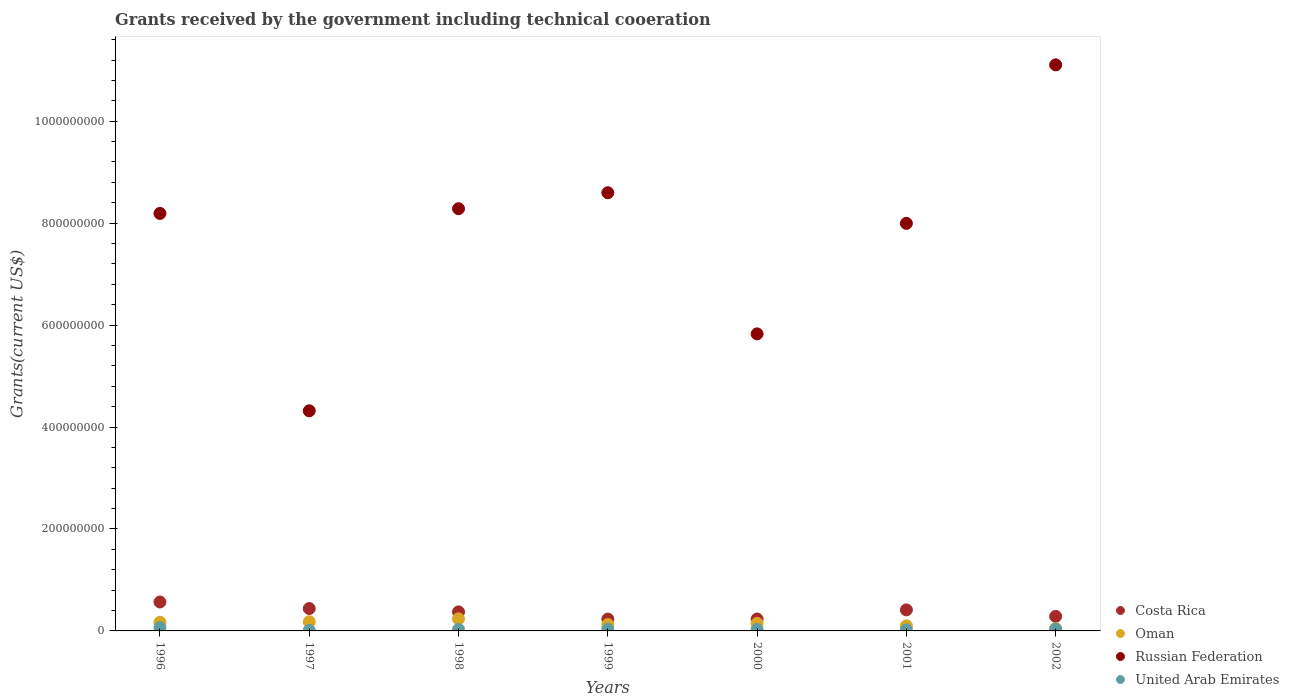How many different coloured dotlines are there?
Your response must be concise. 4. Is the number of dotlines equal to the number of legend labels?
Your response must be concise. Yes. What is the total grants received by the government in United Arab Emirates in 1999?
Keep it short and to the point. 3.33e+06. Across all years, what is the maximum total grants received by the government in Russian Federation?
Your answer should be compact. 1.11e+09. Across all years, what is the minimum total grants received by the government in Costa Rica?
Offer a very short reply. 2.33e+07. In which year was the total grants received by the government in United Arab Emirates maximum?
Your answer should be very brief. 1996. In which year was the total grants received by the government in Costa Rica minimum?
Offer a terse response. 1999. What is the total total grants received by the government in United Arab Emirates in the graph?
Offer a very short reply. 2.27e+07. What is the difference between the total grants received by the government in Costa Rica in 1998 and that in 2002?
Provide a succinct answer. 8.85e+06. What is the difference between the total grants received by the government in Russian Federation in 2001 and the total grants received by the government in United Arab Emirates in 2000?
Give a very brief answer. 7.97e+08. What is the average total grants received by the government in Oman per year?
Give a very brief answer. 1.43e+07. In the year 2000, what is the difference between the total grants received by the government in Russian Federation and total grants received by the government in United Arab Emirates?
Your response must be concise. 5.80e+08. What is the ratio of the total grants received by the government in Russian Federation in 1996 to that in 2002?
Make the answer very short. 0.74. Is the total grants received by the government in United Arab Emirates in 1996 less than that in 1998?
Ensure brevity in your answer.  No. Is the difference between the total grants received by the government in Russian Federation in 1996 and 1999 greater than the difference between the total grants received by the government in United Arab Emirates in 1996 and 1999?
Offer a very short reply. No. What is the difference between the highest and the second highest total grants received by the government in United Arab Emirates?
Your answer should be very brief. 3.23e+06. What is the difference between the highest and the lowest total grants received by the government in Costa Rica?
Offer a very short reply. 3.35e+07. Is it the case that in every year, the sum of the total grants received by the government in Costa Rica and total grants received by the government in Russian Federation  is greater than the total grants received by the government in Oman?
Keep it short and to the point. Yes. Is the total grants received by the government in Russian Federation strictly greater than the total grants received by the government in United Arab Emirates over the years?
Provide a succinct answer. Yes. Is the total grants received by the government in Oman strictly less than the total grants received by the government in Russian Federation over the years?
Provide a short and direct response. Yes. How many dotlines are there?
Provide a short and direct response. 4. Are the values on the major ticks of Y-axis written in scientific E-notation?
Ensure brevity in your answer.  No. Does the graph contain any zero values?
Your response must be concise. No. Where does the legend appear in the graph?
Offer a very short reply. Bottom right. How many legend labels are there?
Offer a terse response. 4. How are the legend labels stacked?
Offer a very short reply. Vertical. What is the title of the graph?
Offer a very short reply. Grants received by the government including technical cooeration. Does "Cambodia" appear as one of the legend labels in the graph?
Your answer should be compact. No. What is the label or title of the Y-axis?
Offer a terse response. Grants(current US$). What is the Grants(current US$) in Costa Rica in 1996?
Ensure brevity in your answer.  5.68e+07. What is the Grants(current US$) of Oman in 1996?
Make the answer very short. 1.68e+07. What is the Grants(current US$) in Russian Federation in 1996?
Offer a terse response. 8.19e+08. What is the Grants(current US$) in United Arab Emirates in 1996?
Offer a very short reply. 6.70e+06. What is the Grants(current US$) of Costa Rica in 1997?
Make the answer very short. 4.39e+07. What is the Grants(current US$) of Oman in 1997?
Give a very brief answer. 1.80e+07. What is the Grants(current US$) in Russian Federation in 1997?
Make the answer very short. 4.32e+08. What is the Grants(current US$) in United Arab Emirates in 1997?
Provide a succinct answer. 1.05e+06. What is the Grants(current US$) of Costa Rica in 1998?
Make the answer very short. 3.74e+07. What is the Grants(current US$) in Oman in 1998?
Provide a succinct answer. 2.37e+07. What is the Grants(current US$) in Russian Federation in 1998?
Keep it short and to the point. 8.28e+08. What is the Grants(current US$) in United Arab Emirates in 1998?
Give a very brief answer. 3.01e+06. What is the Grants(current US$) in Costa Rica in 1999?
Offer a terse response. 2.33e+07. What is the Grants(current US$) in Oman in 1999?
Ensure brevity in your answer.  1.25e+07. What is the Grants(current US$) of Russian Federation in 1999?
Give a very brief answer. 8.60e+08. What is the Grants(current US$) in United Arab Emirates in 1999?
Your answer should be compact. 3.33e+06. What is the Grants(current US$) of Costa Rica in 2000?
Make the answer very short. 2.34e+07. What is the Grants(current US$) of Oman in 2000?
Your answer should be compact. 1.48e+07. What is the Grants(current US$) of Russian Federation in 2000?
Make the answer very short. 5.83e+08. What is the Grants(current US$) of United Arab Emirates in 2000?
Your response must be concise. 3.03e+06. What is the Grants(current US$) in Costa Rica in 2001?
Provide a short and direct response. 4.13e+07. What is the Grants(current US$) in Oman in 2001?
Keep it short and to the point. 9.93e+06. What is the Grants(current US$) in Russian Federation in 2001?
Your answer should be very brief. 8.00e+08. What is the Grants(current US$) of United Arab Emirates in 2001?
Make the answer very short. 2.09e+06. What is the Grants(current US$) of Costa Rica in 2002?
Offer a terse response. 2.85e+07. What is the Grants(current US$) in Oman in 2002?
Offer a very short reply. 4.55e+06. What is the Grants(current US$) of Russian Federation in 2002?
Give a very brief answer. 1.11e+09. What is the Grants(current US$) of United Arab Emirates in 2002?
Your answer should be very brief. 3.47e+06. Across all years, what is the maximum Grants(current US$) of Costa Rica?
Offer a terse response. 5.68e+07. Across all years, what is the maximum Grants(current US$) of Oman?
Provide a short and direct response. 2.37e+07. Across all years, what is the maximum Grants(current US$) of Russian Federation?
Provide a short and direct response. 1.11e+09. Across all years, what is the maximum Grants(current US$) of United Arab Emirates?
Ensure brevity in your answer.  6.70e+06. Across all years, what is the minimum Grants(current US$) in Costa Rica?
Provide a succinct answer. 2.33e+07. Across all years, what is the minimum Grants(current US$) of Oman?
Your answer should be very brief. 4.55e+06. Across all years, what is the minimum Grants(current US$) in Russian Federation?
Provide a succinct answer. 4.32e+08. Across all years, what is the minimum Grants(current US$) in United Arab Emirates?
Your answer should be compact. 1.05e+06. What is the total Grants(current US$) of Costa Rica in the graph?
Provide a succinct answer. 2.54e+08. What is the total Grants(current US$) of Oman in the graph?
Your response must be concise. 1.00e+08. What is the total Grants(current US$) in Russian Federation in the graph?
Offer a very short reply. 5.43e+09. What is the total Grants(current US$) of United Arab Emirates in the graph?
Give a very brief answer. 2.27e+07. What is the difference between the Grants(current US$) in Costa Rica in 1996 and that in 1997?
Make the answer very short. 1.28e+07. What is the difference between the Grants(current US$) of Oman in 1996 and that in 1997?
Provide a short and direct response. -1.19e+06. What is the difference between the Grants(current US$) of Russian Federation in 1996 and that in 1997?
Your answer should be compact. 3.87e+08. What is the difference between the Grants(current US$) of United Arab Emirates in 1996 and that in 1997?
Offer a very short reply. 5.65e+06. What is the difference between the Grants(current US$) of Costa Rica in 1996 and that in 1998?
Give a very brief answer. 1.94e+07. What is the difference between the Grants(current US$) of Oman in 1996 and that in 1998?
Give a very brief answer. -6.86e+06. What is the difference between the Grants(current US$) of Russian Federation in 1996 and that in 1998?
Your response must be concise. -9.23e+06. What is the difference between the Grants(current US$) in United Arab Emirates in 1996 and that in 1998?
Offer a very short reply. 3.69e+06. What is the difference between the Grants(current US$) in Costa Rica in 1996 and that in 1999?
Your answer should be very brief. 3.35e+07. What is the difference between the Grants(current US$) of Oman in 1996 and that in 1999?
Your answer should be compact. 4.31e+06. What is the difference between the Grants(current US$) in Russian Federation in 1996 and that in 1999?
Give a very brief answer. -4.06e+07. What is the difference between the Grants(current US$) of United Arab Emirates in 1996 and that in 1999?
Ensure brevity in your answer.  3.37e+06. What is the difference between the Grants(current US$) of Costa Rica in 1996 and that in 2000?
Give a very brief answer. 3.34e+07. What is the difference between the Grants(current US$) of Oman in 1996 and that in 2000?
Your answer should be very brief. 2.08e+06. What is the difference between the Grants(current US$) in Russian Federation in 1996 and that in 2000?
Your answer should be compact. 2.36e+08. What is the difference between the Grants(current US$) of United Arab Emirates in 1996 and that in 2000?
Keep it short and to the point. 3.67e+06. What is the difference between the Grants(current US$) in Costa Rica in 1996 and that in 2001?
Ensure brevity in your answer.  1.55e+07. What is the difference between the Grants(current US$) of Oman in 1996 and that in 2001?
Give a very brief answer. 6.91e+06. What is the difference between the Grants(current US$) in Russian Federation in 1996 and that in 2001?
Make the answer very short. 1.95e+07. What is the difference between the Grants(current US$) in United Arab Emirates in 1996 and that in 2001?
Your response must be concise. 4.61e+06. What is the difference between the Grants(current US$) of Costa Rica in 1996 and that in 2002?
Your answer should be very brief. 2.83e+07. What is the difference between the Grants(current US$) in Oman in 1996 and that in 2002?
Give a very brief answer. 1.23e+07. What is the difference between the Grants(current US$) in Russian Federation in 1996 and that in 2002?
Provide a short and direct response. -2.91e+08. What is the difference between the Grants(current US$) of United Arab Emirates in 1996 and that in 2002?
Your answer should be very brief. 3.23e+06. What is the difference between the Grants(current US$) in Costa Rica in 1997 and that in 1998?
Make the answer very short. 6.58e+06. What is the difference between the Grants(current US$) in Oman in 1997 and that in 1998?
Offer a terse response. -5.67e+06. What is the difference between the Grants(current US$) in Russian Federation in 1997 and that in 1998?
Offer a terse response. -3.97e+08. What is the difference between the Grants(current US$) of United Arab Emirates in 1997 and that in 1998?
Give a very brief answer. -1.96e+06. What is the difference between the Grants(current US$) of Costa Rica in 1997 and that in 1999?
Provide a short and direct response. 2.07e+07. What is the difference between the Grants(current US$) of Oman in 1997 and that in 1999?
Provide a succinct answer. 5.50e+06. What is the difference between the Grants(current US$) of Russian Federation in 1997 and that in 1999?
Offer a very short reply. -4.28e+08. What is the difference between the Grants(current US$) in United Arab Emirates in 1997 and that in 1999?
Provide a short and direct response. -2.28e+06. What is the difference between the Grants(current US$) in Costa Rica in 1997 and that in 2000?
Provide a short and direct response. 2.05e+07. What is the difference between the Grants(current US$) of Oman in 1997 and that in 2000?
Ensure brevity in your answer.  3.27e+06. What is the difference between the Grants(current US$) of Russian Federation in 1997 and that in 2000?
Ensure brevity in your answer.  -1.51e+08. What is the difference between the Grants(current US$) in United Arab Emirates in 1997 and that in 2000?
Keep it short and to the point. -1.98e+06. What is the difference between the Grants(current US$) of Costa Rica in 1997 and that in 2001?
Offer a terse response. 2.66e+06. What is the difference between the Grants(current US$) in Oman in 1997 and that in 2001?
Ensure brevity in your answer.  8.10e+06. What is the difference between the Grants(current US$) of Russian Federation in 1997 and that in 2001?
Ensure brevity in your answer.  -3.68e+08. What is the difference between the Grants(current US$) of United Arab Emirates in 1997 and that in 2001?
Your response must be concise. -1.04e+06. What is the difference between the Grants(current US$) of Costa Rica in 1997 and that in 2002?
Your answer should be compact. 1.54e+07. What is the difference between the Grants(current US$) of Oman in 1997 and that in 2002?
Your answer should be compact. 1.35e+07. What is the difference between the Grants(current US$) of Russian Federation in 1997 and that in 2002?
Give a very brief answer. -6.79e+08. What is the difference between the Grants(current US$) of United Arab Emirates in 1997 and that in 2002?
Your response must be concise. -2.42e+06. What is the difference between the Grants(current US$) of Costa Rica in 1998 and that in 1999?
Your response must be concise. 1.41e+07. What is the difference between the Grants(current US$) of Oman in 1998 and that in 1999?
Offer a terse response. 1.12e+07. What is the difference between the Grants(current US$) of Russian Federation in 1998 and that in 1999?
Your response must be concise. -3.14e+07. What is the difference between the Grants(current US$) in United Arab Emirates in 1998 and that in 1999?
Offer a very short reply. -3.20e+05. What is the difference between the Grants(current US$) of Costa Rica in 1998 and that in 2000?
Your answer should be compact. 1.40e+07. What is the difference between the Grants(current US$) of Oman in 1998 and that in 2000?
Your response must be concise. 8.94e+06. What is the difference between the Grants(current US$) in Russian Federation in 1998 and that in 2000?
Make the answer very short. 2.46e+08. What is the difference between the Grants(current US$) in United Arab Emirates in 1998 and that in 2000?
Make the answer very short. -2.00e+04. What is the difference between the Grants(current US$) in Costa Rica in 1998 and that in 2001?
Keep it short and to the point. -3.92e+06. What is the difference between the Grants(current US$) in Oman in 1998 and that in 2001?
Provide a succinct answer. 1.38e+07. What is the difference between the Grants(current US$) of Russian Federation in 1998 and that in 2001?
Provide a short and direct response. 2.87e+07. What is the difference between the Grants(current US$) of United Arab Emirates in 1998 and that in 2001?
Provide a succinct answer. 9.20e+05. What is the difference between the Grants(current US$) in Costa Rica in 1998 and that in 2002?
Your response must be concise. 8.85e+06. What is the difference between the Grants(current US$) in Oman in 1998 and that in 2002?
Offer a terse response. 1.92e+07. What is the difference between the Grants(current US$) of Russian Federation in 1998 and that in 2002?
Provide a short and direct response. -2.82e+08. What is the difference between the Grants(current US$) of United Arab Emirates in 1998 and that in 2002?
Give a very brief answer. -4.60e+05. What is the difference between the Grants(current US$) of Costa Rica in 1999 and that in 2000?
Your answer should be compact. -1.30e+05. What is the difference between the Grants(current US$) of Oman in 1999 and that in 2000?
Offer a terse response. -2.23e+06. What is the difference between the Grants(current US$) in Russian Federation in 1999 and that in 2000?
Offer a terse response. 2.77e+08. What is the difference between the Grants(current US$) in United Arab Emirates in 1999 and that in 2000?
Give a very brief answer. 3.00e+05. What is the difference between the Grants(current US$) in Costa Rica in 1999 and that in 2001?
Make the answer very short. -1.80e+07. What is the difference between the Grants(current US$) in Oman in 1999 and that in 2001?
Offer a very short reply. 2.60e+06. What is the difference between the Grants(current US$) in Russian Federation in 1999 and that in 2001?
Provide a succinct answer. 6.01e+07. What is the difference between the Grants(current US$) in United Arab Emirates in 1999 and that in 2001?
Provide a succinct answer. 1.24e+06. What is the difference between the Grants(current US$) in Costa Rica in 1999 and that in 2002?
Your answer should be very brief. -5.23e+06. What is the difference between the Grants(current US$) of Oman in 1999 and that in 2002?
Provide a short and direct response. 7.98e+06. What is the difference between the Grants(current US$) of Russian Federation in 1999 and that in 2002?
Provide a succinct answer. -2.51e+08. What is the difference between the Grants(current US$) in United Arab Emirates in 1999 and that in 2002?
Provide a succinct answer. -1.40e+05. What is the difference between the Grants(current US$) in Costa Rica in 2000 and that in 2001?
Make the answer very short. -1.79e+07. What is the difference between the Grants(current US$) of Oman in 2000 and that in 2001?
Your answer should be very brief. 4.83e+06. What is the difference between the Grants(current US$) of Russian Federation in 2000 and that in 2001?
Ensure brevity in your answer.  -2.17e+08. What is the difference between the Grants(current US$) of United Arab Emirates in 2000 and that in 2001?
Ensure brevity in your answer.  9.40e+05. What is the difference between the Grants(current US$) in Costa Rica in 2000 and that in 2002?
Offer a very short reply. -5.10e+06. What is the difference between the Grants(current US$) in Oman in 2000 and that in 2002?
Your answer should be very brief. 1.02e+07. What is the difference between the Grants(current US$) of Russian Federation in 2000 and that in 2002?
Offer a very short reply. -5.28e+08. What is the difference between the Grants(current US$) of United Arab Emirates in 2000 and that in 2002?
Offer a very short reply. -4.40e+05. What is the difference between the Grants(current US$) of Costa Rica in 2001 and that in 2002?
Offer a terse response. 1.28e+07. What is the difference between the Grants(current US$) in Oman in 2001 and that in 2002?
Your answer should be very brief. 5.38e+06. What is the difference between the Grants(current US$) of Russian Federation in 2001 and that in 2002?
Your answer should be compact. -3.11e+08. What is the difference between the Grants(current US$) of United Arab Emirates in 2001 and that in 2002?
Your response must be concise. -1.38e+06. What is the difference between the Grants(current US$) in Costa Rica in 1996 and the Grants(current US$) in Oman in 1997?
Provide a short and direct response. 3.87e+07. What is the difference between the Grants(current US$) of Costa Rica in 1996 and the Grants(current US$) of Russian Federation in 1997?
Provide a succinct answer. -3.75e+08. What is the difference between the Grants(current US$) of Costa Rica in 1996 and the Grants(current US$) of United Arab Emirates in 1997?
Offer a terse response. 5.57e+07. What is the difference between the Grants(current US$) of Oman in 1996 and the Grants(current US$) of Russian Federation in 1997?
Your response must be concise. -4.15e+08. What is the difference between the Grants(current US$) of Oman in 1996 and the Grants(current US$) of United Arab Emirates in 1997?
Your answer should be very brief. 1.58e+07. What is the difference between the Grants(current US$) of Russian Federation in 1996 and the Grants(current US$) of United Arab Emirates in 1997?
Your answer should be very brief. 8.18e+08. What is the difference between the Grants(current US$) in Costa Rica in 1996 and the Grants(current US$) in Oman in 1998?
Provide a short and direct response. 3.31e+07. What is the difference between the Grants(current US$) of Costa Rica in 1996 and the Grants(current US$) of Russian Federation in 1998?
Your response must be concise. -7.72e+08. What is the difference between the Grants(current US$) in Costa Rica in 1996 and the Grants(current US$) in United Arab Emirates in 1998?
Make the answer very short. 5.38e+07. What is the difference between the Grants(current US$) in Oman in 1996 and the Grants(current US$) in Russian Federation in 1998?
Offer a very short reply. -8.12e+08. What is the difference between the Grants(current US$) in Oman in 1996 and the Grants(current US$) in United Arab Emirates in 1998?
Provide a succinct answer. 1.38e+07. What is the difference between the Grants(current US$) in Russian Federation in 1996 and the Grants(current US$) in United Arab Emirates in 1998?
Offer a terse response. 8.16e+08. What is the difference between the Grants(current US$) of Costa Rica in 1996 and the Grants(current US$) of Oman in 1999?
Provide a short and direct response. 4.42e+07. What is the difference between the Grants(current US$) in Costa Rica in 1996 and the Grants(current US$) in Russian Federation in 1999?
Your response must be concise. -8.03e+08. What is the difference between the Grants(current US$) of Costa Rica in 1996 and the Grants(current US$) of United Arab Emirates in 1999?
Your answer should be compact. 5.34e+07. What is the difference between the Grants(current US$) in Oman in 1996 and the Grants(current US$) in Russian Federation in 1999?
Your answer should be compact. -8.43e+08. What is the difference between the Grants(current US$) in Oman in 1996 and the Grants(current US$) in United Arab Emirates in 1999?
Give a very brief answer. 1.35e+07. What is the difference between the Grants(current US$) in Russian Federation in 1996 and the Grants(current US$) in United Arab Emirates in 1999?
Make the answer very short. 8.16e+08. What is the difference between the Grants(current US$) in Costa Rica in 1996 and the Grants(current US$) in Oman in 2000?
Offer a very short reply. 4.20e+07. What is the difference between the Grants(current US$) of Costa Rica in 1996 and the Grants(current US$) of Russian Federation in 2000?
Offer a very short reply. -5.26e+08. What is the difference between the Grants(current US$) of Costa Rica in 1996 and the Grants(current US$) of United Arab Emirates in 2000?
Offer a very short reply. 5.37e+07. What is the difference between the Grants(current US$) of Oman in 1996 and the Grants(current US$) of Russian Federation in 2000?
Make the answer very short. -5.66e+08. What is the difference between the Grants(current US$) of Oman in 1996 and the Grants(current US$) of United Arab Emirates in 2000?
Offer a terse response. 1.38e+07. What is the difference between the Grants(current US$) in Russian Federation in 1996 and the Grants(current US$) in United Arab Emirates in 2000?
Offer a terse response. 8.16e+08. What is the difference between the Grants(current US$) in Costa Rica in 1996 and the Grants(current US$) in Oman in 2001?
Your answer should be very brief. 4.68e+07. What is the difference between the Grants(current US$) in Costa Rica in 1996 and the Grants(current US$) in Russian Federation in 2001?
Make the answer very short. -7.43e+08. What is the difference between the Grants(current US$) of Costa Rica in 1996 and the Grants(current US$) of United Arab Emirates in 2001?
Offer a very short reply. 5.47e+07. What is the difference between the Grants(current US$) of Oman in 1996 and the Grants(current US$) of Russian Federation in 2001?
Provide a succinct answer. -7.83e+08. What is the difference between the Grants(current US$) of Oman in 1996 and the Grants(current US$) of United Arab Emirates in 2001?
Provide a succinct answer. 1.48e+07. What is the difference between the Grants(current US$) in Russian Federation in 1996 and the Grants(current US$) in United Arab Emirates in 2001?
Your response must be concise. 8.17e+08. What is the difference between the Grants(current US$) of Costa Rica in 1996 and the Grants(current US$) of Oman in 2002?
Your answer should be very brief. 5.22e+07. What is the difference between the Grants(current US$) in Costa Rica in 1996 and the Grants(current US$) in Russian Federation in 2002?
Provide a short and direct response. -1.05e+09. What is the difference between the Grants(current US$) of Costa Rica in 1996 and the Grants(current US$) of United Arab Emirates in 2002?
Your answer should be very brief. 5.33e+07. What is the difference between the Grants(current US$) of Oman in 1996 and the Grants(current US$) of Russian Federation in 2002?
Offer a terse response. -1.09e+09. What is the difference between the Grants(current US$) of Oman in 1996 and the Grants(current US$) of United Arab Emirates in 2002?
Your response must be concise. 1.34e+07. What is the difference between the Grants(current US$) in Russian Federation in 1996 and the Grants(current US$) in United Arab Emirates in 2002?
Your response must be concise. 8.16e+08. What is the difference between the Grants(current US$) in Costa Rica in 1997 and the Grants(current US$) in Oman in 1998?
Your response must be concise. 2.02e+07. What is the difference between the Grants(current US$) in Costa Rica in 1997 and the Grants(current US$) in Russian Federation in 1998?
Provide a succinct answer. -7.84e+08. What is the difference between the Grants(current US$) of Costa Rica in 1997 and the Grants(current US$) of United Arab Emirates in 1998?
Keep it short and to the point. 4.09e+07. What is the difference between the Grants(current US$) in Oman in 1997 and the Grants(current US$) in Russian Federation in 1998?
Your response must be concise. -8.10e+08. What is the difference between the Grants(current US$) of Oman in 1997 and the Grants(current US$) of United Arab Emirates in 1998?
Your answer should be compact. 1.50e+07. What is the difference between the Grants(current US$) in Russian Federation in 1997 and the Grants(current US$) in United Arab Emirates in 1998?
Make the answer very short. 4.29e+08. What is the difference between the Grants(current US$) in Costa Rica in 1997 and the Grants(current US$) in Oman in 1999?
Your answer should be compact. 3.14e+07. What is the difference between the Grants(current US$) of Costa Rica in 1997 and the Grants(current US$) of Russian Federation in 1999?
Give a very brief answer. -8.16e+08. What is the difference between the Grants(current US$) in Costa Rica in 1997 and the Grants(current US$) in United Arab Emirates in 1999?
Make the answer very short. 4.06e+07. What is the difference between the Grants(current US$) of Oman in 1997 and the Grants(current US$) of Russian Federation in 1999?
Your response must be concise. -8.42e+08. What is the difference between the Grants(current US$) in Oman in 1997 and the Grants(current US$) in United Arab Emirates in 1999?
Offer a terse response. 1.47e+07. What is the difference between the Grants(current US$) of Russian Federation in 1997 and the Grants(current US$) of United Arab Emirates in 1999?
Ensure brevity in your answer.  4.28e+08. What is the difference between the Grants(current US$) of Costa Rica in 1997 and the Grants(current US$) of Oman in 2000?
Offer a very short reply. 2.92e+07. What is the difference between the Grants(current US$) in Costa Rica in 1997 and the Grants(current US$) in Russian Federation in 2000?
Ensure brevity in your answer.  -5.39e+08. What is the difference between the Grants(current US$) in Costa Rica in 1997 and the Grants(current US$) in United Arab Emirates in 2000?
Give a very brief answer. 4.09e+07. What is the difference between the Grants(current US$) of Oman in 1997 and the Grants(current US$) of Russian Federation in 2000?
Give a very brief answer. -5.65e+08. What is the difference between the Grants(current US$) in Oman in 1997 and the Grants(current US$) in United Arab Emirates in 2000?
Give a very brief answer. 1.50e+07. What is the difference between the Grants(current US$) in Russian Federation in 1997 and the Grants(current US$) in United Arab Emirates in 2000?
Offer a terse response. 4.29e+08. What is the difference between the Grants(current US$) in Costa Rica in 1997 and the Grants(current US$) in Oman in 2001?
Keep it short and to the point. 3.40e+07. What is the difference between the Grants(current US$) in Costa Rica in 1997 and the Grants(current US$) in Russian Federation in 2001?
Keep it short and to the point. -7.56e+08. What is the difference between the Grants(current US$) of Costa Rica in 1997 and the Grants(current US$) of United Arab Emirates in 2001?
Give a very brief answer. 4.18e+07. What is the difference between the Grants(current US$) of Oman in 1997 and the Grants(current US$) of Russian Federation in 2001?
Make the answer very short. -7.82e+08. What is the difference between the Grants(current US$) in Oman in 1997 and the Grants(current US$) in United Arab Emirates in 2001?
Keep it short and to the point. 1.59e+07. What is the difference between the Grants(current US$) in Russian Federation in 1997 and the Grants(current US$) in United Arab Emirates in 2001?
Offer a terse response. 4.30e+08. What is the difference between the Grants(current US$) in Costa Rica in 1997 and the Grants(current US$) in Oman in 2002?
Your answer should be very brief. 3.94e+07. What is the difference between the Grants(current US$) in Costa Rica in 1997 and the Grants(current US$) in Russian Federation in 2002?
Provide a succinct answer. -1.07e+09. What is the difference between the Grants(current US$) of Costa Rica in 1997 and the Grants(current US$) of United Arab Emirates in 2002?
Keep it short and to the point. 4.05e+07. What is the difference between the Grants(current US$) of Oman in 1997 and the Grants(current US$) of Russian Federation in 2002?
Keep it short and to the point. -1.09e+09. What is the difference between the Grants(current US$) in Oman in 1997 and the Grants(current US$) in United Arab Emirates in 2002?
Your answer should be very brief. 1.46e+07. What is the difference between the Grants(current US$) of Russian Federation in 1997 and the Grants(current US$) of United Arab Emirates in 2002?
Offer a very short reply. 4.28e+08. What is the difference between the Grants(current US$) of Costa Rica in 1998 and the Grants(current US$) of Oman in 1999?
Give a very brief answer. 2.48e+07. What is the difference between the Grants(current US$) of Costa Rica in 1998 and the Grants(current US$) of Russian Federation in 1999?
Provide a short and direct response. -8.22e+08. What is the difference between the Grants(current US$) in Costa Rica in 1998 and the Grants(current US$) in United Arab Emirates in 1999?
Your answer should be compact. 3.40e+07. What is the difference between the Grants(current US$) in Oman in 1998 and the Grants(current US$) in Russian Federation in 1999?
Ensure brevity in your answer.  -8.36e+08. What is the difference between the Grants(current US$) in Oman in 1998 and the Grants(current US$) in United Arab Emirates in 1999?
Provide a succinct answer. 2.04e+07. What is the difference between the Grants(current US$) of Russian Federation in 1998 and the Grants(current US$) of United Arab Emirates in 1999?
Offer a terse response. 8.25e+08. What is the difference between the Grants(current US$) of Costa Rica in 1998 and the Grants(current US$) of Oman in 2000?
Offer a terse response. 2.26e+07. What is the difference between the Grants(current US$) of Costa Rica in 1998 and the Grants(current US$) of Russian Federation in 2000?
Offer a very short reply. -5.45e+08. What is the difference between the Grants(current US$) of Costa Rica in 1998 and the Grants(current US$) of United Arab Emirates in 2000?
Keep it short and to the point. 3.43e+07. What is the difference between the Grants(current US$) of Oman in 1998 and the Grants(current US$) of Russian Federation in 2000?
Provide a short and direct response. -5.59e+08. What is the difference between the Grants(current US$) in Oman in 1998 and the Grants(current US$) in United Arab Emirates in 2000?
Keep it short and to the point. 2.07e+07. What is the difference between the Grants(current US$) in Russian Federation in 1998 and the Grants(current US$) in United Arab Emirates in 2000?
Provide a succinct answer. 8.25e+08. What is the difference between the Grants(current US$) of Costa Rica in 1998 and the Grants(current US$) of Oman in 2001?
Offer a terse response. 2.74e+07. What is the difference between the Grants(current US$) in Costa Rica in 1998 and the Grants(current US$) in Russian Federation in 2001?
Ensure brevity in your answer.  -7.62e+08. What is the difference between the Grants(current US$) of Costa Rica in 1998 and the Grants(current US$) of United Arab Emirates in 2001?
Provide a succinct answer. 3.53e+07. What is the difference between the Grants(current US$) in Oman in 1998 and the Grants(current US$) in Russian Federation in 2001?
Ensure brevity in your answer.  -7.76e+08. What is the difference between the Grants(current US$) in Oman in 1998 and the Grants(current US$) in United Arab Emirates in 2001?
Ensure brevity in your answer.  2.16e+07. What is the difference between the Grants(current US$) of Russian Federation in 1998 and the Grants(current US$) of United Arab Emirates in 2001?
Your response must be concise. 8.26e+08. What is the difference between the Grants(current US$) in Costa Rica in 1998 and the Grants(current US$) in Oman in 2002?
Make the answer very short. 3.28e+07. What is the difference between the Grants(current US$) of Costa Rica in 1998 and the Grants(current US$) of Russian Federation in 2002?
Provide a short and direct response. -1.07e+09. What is the difference between the Grants(current US$) in Costa Rica in 1998 and the Grants(current US$) in United Arab Emirates in 2002?
Give a very brief answer. 3.39e+07. What is the difference between the Grants(current US$) of Oman in 1998 and the Grants(current US$) of Russian Federation in 2002?
Your answer should be very brief. -1.09e+09. What is the difference between the Grants(current US$) of Oman in 1998 and the Grants(current US$) of United Arab Emirates in 2002?
Keep it short and to the point. 2.02e+07. What is the difference between the Grants(current US$) of Russian Federation in 1998 and the Grants(current US$) of United Arab Emirates in 2002?
Provide a succinct answer. 8.25e+08. What is the difference between the Grants(current US$) in Costa Rica in 1999 and the Grants(current US$) in Oman in 2000?
Give a very brief answer. 8.51e+06. What is the difference between the Grants(current US$) in Costa Rica in 1999 and the Grants(current US$) in Russian Federation in 2000?
Provide a succinct answer. -5.60e+08. What is the difference between the Grants(current US$) in Costa Rica in 1999 and the Grants(current US$) in United Arab Emirates in 2000?
Keep it short and to the point. 2.02e+07. What is the difference between the Grants(current US$) in Oman in 1999 and the Grants(current US$) in Russian Federation in 2000?
Ensure brevity in your answer.  -5.70e+08. What is the difference between the Grants(current US$) in Oman in 1999 and the Grants(current US$) in United Arab Emirates in 2000?
Offer a terse response. 9.50e+06. What is the difference between the Grants(current US$) in Russian Federation in 1999 and the Grants(current US$) in United Arab Emirates in 2000?
Your answer should be very brief. 8.57e+08. What is the difference between the Grants(current US$) of Costa Rica in 1999 and the Grants(current US$) of Oman in 2001?
Give a very brief answer. 1.33e+07. What is the difference between the Grants(current US$) in Costa Rica in 1999 and the Grants(current US$) in Russian Federation in 2001?
Ensure brevity in your answer.  -7.76e+08. What is the difference between the Grants(current US$) of Costa Rica in 1999 and the Grants(current US$) of United Arab Emirates in 2001?
Keep it short and to the point. 2.12e+07. What is the difference between the Grants(current US$) in Oman in 1999 and the Grants(current US$) in Russian Federation in 2001?
Your response must be concise. -7.87e+08. What is the difference between the Grants(current US$) in Oman in 1999 and the Grants(current US$) in United Arab Emirates in 2001?
Ensure brevity in your answer.  1.04e+07. What is the difference between the Grants(current US$) in Russian Federation in 1999 and the Grants(current US$) in United Arab Emirates in 2001?
Your response must be concise. 8.58e+08. What is the difference between the Grants(current US$) of Costa Rica in 1999 and the Grants(current US$) of Oman in 2002?
Make the answer very short. 1.87e+07. What is the difference between the Grants(current US$) in Costa Rica in 1999 and the Grants(current US$) in Russian Federation in 2002?
Your answer should be very brief. -1.09e+09. What is the difference between the Grants(current US$) in Costa Rica in 1999 and the Grants(current US$) in United Arab Emirates in 2002?
Give a very brief answer. 1.98e+07. What is the difference between the Grants(current US$) of Oman in 1999 and the Grants(current US$) of Russian Federation in 2002?
Give a very brief answer. -1.10e+09. What is the difference between the Grants(current US$) of Oman in 1999 and the Grants(current US$) of United Arab Emirates in 2002?
Your answer should be compact. 9.06e+06. What is the difference between the Grants(current US$) in Russian Federation in 1999 and the Grants(current US$) in United Arab Emirates in 2002?
Make the answer very short. 8.56e+08. What is the difference between the Grants(current US$) of Costa Rica in 2000 and the Grants(current US$) of Oman in 2001?
Offer a very short reply. 1.35e+07. What is the difference between the Grants(current US$) in Costa Rica in 2000 and the Grants(current US$) in Russian Federation in 2001?
Your response must be concise. -7.76e+08. What is the difference between the Grants(current US$) in Costa Rica in 2000 and the Grants(current US$) in United Arab Emirates in 2001?
Offer a very short reply. 2.13e+07. What is the difference between the Grants(current US$) of Oman in 2000 and the Grants(current US$) of Russian Federation in 2001?
Your answer should be very brief. -7.85e+08. What is the difference between the Grants(current US$) in Oman in 2000 and the Grants(current US$) in United Arab Emirates in 2001?
Offer a very short reply. 1.27e+07. What is the difference between the Grants(current US$) of Russian Federation in 2000 and the Grants(current US$) of United Arab Emirates in 2001?
Offer a very short reply. 5.81e+08. What is the difference between the Grants(current US$) of Costa Rica in 2000 and the Grants(current US$) of Oman in 2002?
Your response must be concise. 1.88e+07. What is the difference between the Grants(current US$) in Costa Rica in 2000 and the Grants(current US$) in Russian Federation in 2002?
Your answer should be compact. -1.09e+09. What is the difference between the Grants(current US$) of Costa Rica in 2000 and the Grants(current US$) of United Arab Emirates in 2002?
Provide a short and direct response. 1.99e+07. What is the difference between the Grants(current US$) in Oman in 2000 and the Grants(current US$) in Russian Federation in 2002?
Make the answer very short. -1.10e+09. What is the difference between the Grants(current US$) of Oman in 2000 and the Grants(current US$) of United Arab Emirates in 2002?
Ensure brevity in your answer.  1.13e+07. What is the difference between the Grants(current US$) of Russian Federation in 2000 and the Grants(current US$) of United Arab Emirates in 2002?
Provide a short and direct response. 5.79e+08. What is the difference between the Grants(current US$) in Costa Rica in 2001 and the Grants(current US$) in Oman in 2002?
Keep it short and to the point. 3.67e+07. What is the difference between the Grants(current US$) in Costa Rica in 2001 and the Grants(current US$) in Russian Federation in 2002?
Offer a terse response. -1.07e+09. What is the difference between the Grants(current US$) of Costa Rica in 2001 and the Grants(current US$) of United Arab Emirates in 2002?
Give a very brief answer. 3.78e+07. What is the difference between the Grants(current US$) in Oman in 2001 and the Grants(current US$) in Russian Federation in 2002?
Offer a very short reply. -1.10e+09. What is the difference between the Grants(current US$) in Oman in 2001 and the Grants(current US$) in United Arab Emirates in 2002?
Your answer should be compact. 6.46e+06. What is the difference between the Grants(current US$) in Russian Federation in 2001 and the Grants(current US$) in United Arab Emirates in 2002?
Provide a short and direct response. 7.96e+08. What is the average Grants(current US$) of Costa Rica per year?
Your answer should be very brief. 3.64e+07. What is the average Grants(current US$) in Oman per year?
Provide a short and direct response. 1.43e+07. What is the average Grants(current US$) in Russian Federation per year?
Provide a succinct answer. 7.76e+08. What is the average Grants(current US$) in United Arab Emirates per year?
Provide a short and direct response. 3.24e+06. In the year 1996, what is the difference between the Grants(current US$) of Costa Rica and Grants(current US$) of Oman?
Make the answer very short. 3.99e+07. In the year 1996, what is the difference between the Grants(current US$) in Costa Rica and Grants(current US$) in Russian Federation?
Provide a succinct answer. -7.62e+08. In the year 1996, what is the difference between the Grants(current US$) in Costa Rica and Grants(current US$) in United Arab Emirates?
Your answer should be very brief. 5.01e+07. In the year 1996, what is the difference between the Grants(current US$) in Oman and Grants(current US$) in Russian Federation?
Provide a short and direct response. -8.02e+08. In the year 1996, what is the difference between the Grants(current US$) in Oman and Grants(current US$) in United Arab Emirates?
Give a very brief answer. 1.01e+07. In the year 1996, what is the difference between the Grants(current US$) of Russian Federation and Grants(current US$) of United Arab Emirates?
Provide a short and direct response. 8.12e+08. In the year 1997, what is the difference between the Grants(current US$) of Costa Rica and Grants(current US$) of Oman?
Your answer should be very brief. 2.59e+07. In the year 1997, what is the difference between the Grants(current US$) in Costa Rica and Grants(current US$) in Russian Federation?
Provide a succinct answer. -3.88e+08. In the year 1997, what is the difference between the Grants(current US$) of Costa Rica and Grants(current US$) of United Arab Emirates?
Offer a terse response. 4.29e+07. In the year 1997, what is the difference between the Grants(current US$) in Oman and Grants(current US$) in Russian Federation?
Keep it short and to the point. -4.14e+08. In the year 1997, what is the difference between the Grants(current US$) of Oman and Grants(current US$) of United Arab Emirates?
Ensure brevity in your answer.  1.70e+07. In the year 1997, what is the difference between the Grants(current US$) in Russian Federation and Grants(current US$) in United Arab Emirates?
Keep it short and to the point. 4.31e+08. In the year 1998, what is the difference between the Grants(current US$) of Costa Rica and Grants(current US$) of Oman?
Provide a short and direct response. 1.36e+07. In the year 1998, what is the difference between the Grants(current US$) in Costa Rica and Grants(current US$) in Russian Federation?
Ensure brevity in your answer.  -7.91e+08. In the year 1998, what is the difference between the Grants(current US$) in Costa Rica and Grants(current US$) in United Arab Emirates?
Your answer should be very brief. 3.43e+07. In the year 1998, what is the difference between the Grants(current US$) in Oman and Grants(current US$) in Russian Federation?
Offer a terse response. -8.05e+08. In the year 1998, what is the difference between the Grants(current US$) of Oman and Grants(current US$) of United Arab Emirates?
Your answer should be compact. 2.07e+07. In the year 1998, what is the difference between the Grants(current US$) in Russian Federation and Grants(current US$) in United Arab Emirates?
Ensure brevity in your answer.  8.25e+08. In the year 1999, what is the difference between the Grants(current US$) in Costa Rica and Grants(current US$) in Oman?
Ensure brevity in your answer.  1.07e+07. In the year 1999, what is the difference between the Grants(current US$) of Costa Rica and Grants(current US$) of Russian Federation?
Your answer should be very brief. -8.36e+08. In the year 1999, what is the difference between the Grants(current US$) in Costa Rica and Grants(current US$) in United Arab Emirates?
Ensure brevity in your answer.  1.99e+07. In the year 1999, what is the difference between the Grants(current US$) of Oman and Grants(current US$) of Russian Federation?
Offer a terse response. -8.47e+08. In the year 1999, what is the difference between the Grants(current US$) of Oman and Grants(current US$) of United Arab Emirates?
Make the answer very short. 9.20e+06. In the year 1999, what is the difference between the Grants(current US$) of Russian Federation and Grants(current US$) of United Arab Emirates?
Your answer should be compact. 8.56e+08. In the year 2000, what is the difference between the Grants(current US$) in Costa Rica and Grants(current US$) in Oman?
Make the answer very short. 8.64e+06. In the year 2000, what is the difference between the Grants(current US$) in Costa Rica and Grants(current US$) in Russian Federation?
Ensure brevity in your answer.  -5.59e+08. In the year 2000, what is the difference between the Grants(current US$) of Costa Rica and Grants(current US$) of United Arab Emirates?
Your answer should be compact. 2.04e+07. In the year 2000, what is the difference between the Grants(current US$) in Oman and Grants(current US$) in Russian Federation?
Your response must be concise. -5.68e+08. In the year 2000, what is the difference between the Grants(current US$) in Oman and Grants(current US$) in United Arab Emirates?
Keep it short and to the point. 1.17e+07. In the year 2000, what is the difference between the Grants(current US$) of Russian Federation and Grants(current US$) of United Arab Emirates?
Your response must be concise. 5.80e+08. In the year 2001, what is the difference between the Grants(current US$) of Costa Rica and Grants(current US$) of Oman?
Your response must be concise. 3.13e+07. In the year 2001, what is the difference between the Grants(current US$) of Costa Rica and Grants(current US$) of Russian Federation?
Your answer should be very brief. -7.58e+08. In the year 2001, what is the difference between the Grants(current US$) in Costa Rica and Grants(current US$) in United Arab Emirates?
Keep it short and to the point. 3.92e+07. In the year 2001, what is the difference between the Grants(current US$) of Oman and Grants(current US$) of Russian Federation?
Provide a succinct answer. -7.90e+08. In the year 2001, what is the difference between the Grants(current US$) of Oman and Grants(current US$) of United Arab Emirates?
Offer a terse response. 7.84e+06. In the year 2001, what is the difference between the Grants(current US$) in Russian Federation and Grants(current US$) in United Arab Emirates?
Your answer should be very brief. 7.98e+08. In the year 2002, what is the difference between the Grants(current US$) in Costa Rica and Grants(current US$) in Oman?
Provide a succinct answer. 2.40e+07. In the year 2002, what is the difference between the Grants(current US$) in Costa Rica and Grants(current US$) in Russian Federation?
Provide a succinct answer. -1.08e+09. In the year 2002, what is the difference between the Grants(current US$) of Costa Rica and Grants(current US$) of United Arab Emirates?
Provide a short and direct response. 2.50e+07. In the year 2002, what is the difference between the Grants(current US$) of Oman and Grants(current US$) of Russian Federation?
Offer a terse response. -1.11e+09. In the year 2002, what is the difference between the Grants(current US$) in Oman and Grants(current US$) in United Arab Emirates?
Provide a short and direct response. 1.08e+06. In the year 2002, what is the difference between the Grants(current US$) in Russian Federation and Grants(current US$) in United Arab Emirates?
Provide a succinct answer. 1.11e+09. What is the ratio of the Grants(current US$) in Costa Rica in 1996 to that in 1997?
Your response must be concise. 1.29. What is the ratio of the Grants(current US$) of Oman in 1996 to that in 1997?
Ensure brevity in your answer.  0.93. What is the ratio of the Grants(current US$) of Russian Federation in 1996 to that in 1997?
Keep it short and to the point. 1.9. What is the ratio of the Grants(current US$) of United Arab Emirates in 1996 to that in 1997?
Make the answer very short. 6.38. What is the ratio of the Grants(current US$) of Costa Rica in 1996 to that in 1998?
Offer a very short reply. 1.52. What is the ratio of the Grants(current US$) of Oman in 1996 to that in 1998?
Provide a succinct answer. 0.71. What is the ratio of the Grants(current US$) of Russian Federation in 1996 to that in 1998?
Provide a succinct answer. 0.99. What is the ratio of the Grants(current US$) of United Arab Emirates in 1996 to that in 1998?
Your answer should be very brief. 2.23. What is the ratio of the Grants(current US$) of Costa Rica in 1996 to that in 1999?
Provide a short and direct response. 2.44. What is the ratio of the Grants(current US$) in Oman in 1996 to that in 1999?
Provide a short and direct response. 1.34. What is the ratio of the Grants(current US$) in Russian Federation in 1996 to that in 1999?
Make the answer very short. 0.95. What is the ratio of the Grants(current US$) of United Arab Emirates in 1996 to that in 1999?
Provide a succinct answer. 2.01. What is the ratio of the Grants(current US$) in Costa Rica in 1996 to that in 2000?
Your response must be concise. 2.43. What is the ratio of the Grants(current US$) of Oman in 1996 to that in 2000?
Offer a terse response. 1.14. What is the ratio of the Grants(current US$) in Russian Federation in 1996 to that in 2000?
Offer a terse response. 1.41. What is the ratio of the Grants(current US$) of United Arab Emirates in 1996 to that in 2000?
Keep it short and to the point. 2.21. What is the ratio of the Grants(current US$) in Costa Rica in 1996 to that in 2001?
Give a very brief answer. 1.38. What is the ratio of the Grants(current US$) in Oman in 1996 to that in 2001?
Your answer should be compact. 1.7. What is the ratio of the Grants(current US$) of Russian Federation in 1996 to that in 2001?
Ensure brevity in your answer.  1.02. What is the ratio of the Grants(current US$) of United Arab Emirates in 1996 to that in 2001?
Provide a short and direct response. 3.21. What is the ratio of the Grants(current US$) in Costa Rica in 1996 to that in 2002?
Provide a succinct answer. 1.99. What is the ratio of the Grants(current US$) of Oman in 1996 to that in 2002?
Ensure brevity in your answer.  3.7. What is the ratio of the Grants(current US$) of Russian Federation in 1996 to that in 2002?
Ensure brevity in your answer.  0.74. What is the ratio of the Grants(current US$) of United Arab Emirates in 1996 to that in 2002?
Your answer should be very brief. 1.93. What is the ratio of the Grants(current US$) in Costa Rica in 1997 to that in 1998?
Provide a short and direct response. 1.18. What is the ratio of the Grants(current US$) in Oman in 1997 to that in 1998?
Make the answer very short. 0.76. What is the ratio of the Grants(current US$) in Russian Federation in 1997 to that in 1998?
Provide a succinct answer. 0.52. What is the ratio of the Grants(current US$) of United Arab Emirates in 1997 to that in 1998?
Ensure brevity in your answer.  0.35. What is the ratio of the Grants(current US$) of Costa Rica in 1997 to that in 1999?
Provide a short and direct response. 1.89. What is the ratio of the Grants(current US$) of Oman in 1997 to that in 1999?
Offer a terse response. 1.44. What is the ratio of the Grants(current US$) in Russian Federation in 1997 to that in 1999?
Your response must be concise. 0.5. What is the ratio of the Grants(current US$) of United Arab Emirates in 1997 to that in 1999?
Make the answer very short. 0.32. What is the ratio of the Grants(current US$) of Costa Rica in 1997 to that in 2000?
Offer a terse response. 1.88. What is the ratio of the Grants(current US$) in Oman in 1997 to that in 2000?
Your answer should be very brief. 1.22. What is the ratio of the Grants(current US$) of Russian Federation in 1997 to that in 2000?
Your answer should be compact. 0.74. What is the ratio of the Grants(current US$) in United Arab Emirates in 1997 to that in 2000?
Make the answer very short. 0.35. What is the ratio of the Grants(current US$) in Costa Rica in 1997 to that in 2001?
Give a very brief answer. 1.06. What is the ratio of the Grants(current US$) of Oman in 1997 to that in 2001?
Offer a terse response. 1.82. What is the ratio of the Grants(current US$) in Russian Federation in 1997 to that in 2001?
Keep it short and to the point. 0.54. What is the ratio of the Grants(current US$) in United Arab Emirates in 1997 to that in 2001?
Ensure brevity in your answer.  0.5. What is the ratio of the Grants(current US$) of Costa Rica in 1997 to that in 2002?
Make the answer very short. 1.54. What is the ratio of the Grants(current US$) of Oman in 1997 to that in 2002?
Offer a terse response. 3.96. What is the ratio of the Grants(current US$) in Russian Federation in 1997 to that in 2002?
Your answer should be very brief. 0.39. What is the ratio of the Grants(current US$) in United Arab Emirates in 1997 to that in 2002?
Give a very brief answer. 0.3. What is the ratio of the Grants(current US$) in Costa Rica in 1998 to that in 1999?
Your answer should be compact. 1.61. What is the ratio of the Grants(current US$) of Oman in 1998 to that in 1999?
Offer a very short reply. 1.89. What is the ratio of the Grants(current US$) of Russian Federation in 1998 to that in 1999?
Provide a short and direct response. 0.96. What is the ratio of the Grants(current US$) in United Arab Emirates in 1998 to that in 1999?
Make the answer very short. 0.9. What is the ratio of the Grants(current US$) in Costa Rica in 1998 to that in 2000?
Your answer should be very brief. 1.6. What is the ratio of the Grants(current US$) in Oman in 1998 to that in 2000?
Offer a terse response. 1.61. What is the ratio of the Grants(current US$) in Russian Federation in 1998 to that in 2000?
Your answer should be very brief. 1.42. What is the ratio of the Grants(current US$) of Costa Rica in 1998 to that in 2001?
Ensure brevity in your answer.  0.91. What is the ratio of the Grants(current US$) in Oman in 1998 to that in 2001?
Make the answer very short. 2.39. What is the ratio of the Grants(current US$) in Russian Federation in 1998 to that in 2001?
Ensure brevity in your answer.  1.04. What is the ratio of the Grants(current US$) in United Arab Emirates in 1998 to that in 2001?
Your answer should be very brief. 1.44. What is the ratio of the Grants(current US$) of Costa Rica in 1998 to that in 2002?
Provide a short and direct response. 1.31. What is the ratio of the Grants(current US$) in Oman in 1998 to that in 2002?
Your response must be concise. 5.21. What is the ratio of the Grants(current US$) of Russian Federation in 1998 to that in 2002?
Provide a short and direct response. 0.75. What is the ratio of the Grants(current US$) of United Arab Emirates in 1998 to that in 2002?
Ensure brevity in your answer.  0.87. What is the ratio of the Grants(current US$) in Costa Rica in 1999 to that in 2000?
Make the answer very short. 0.99. What is the ratio of the Grants(current US$) of Oman in 1999 to that in 2000?
Provide a succinct answer. 0.85. What is the ratio of the Grants(current US$) of Russian Federation in 1999 to that in 2000?
Make the answer very short. 1.48. What is the ratio of the Grants(current US$) of United Arab Emirates in 1999 to that in 2000?
Offer a very short reply. 1.1. What is the ratio of the Grants(current US$) in Costa Rica in 1999 to that in 2001?
Keep it short and to the point. 0.56. What is the ratio of the Grants(current US$) of Oman in 1999 to that in 2001?
Make the answer very short. 1.26. What is the ratio of the Grants(current US$) of Russian Federation in 1999 to that in 2001?
Offer a terse response. 1.08. What is the ratio of the Grants(current US$) in United Arab Emirates in 1999 to that in 2001?
Your answer should be very brief. 1.59. What is the ratio of the Grants(current US$) of Costa Rica in 1999 to that in 2002?
Give a very brief answer. 0.82. What is the ratio of the Grants(current US$) of Oman in 1999 to that in 2002?
Your answer should be compact. 2.75. What is the ratio of the Grants(current US$) of Russian Federation in 1999 to that in 2002?
Provide a succinct answer. 0.77. What is the ratio of the Grants(current US$) in United Arab Emirates in 1999 to that in 2002?
Provide a short and direct response. 0.96. What is the ratio of the Grants(current US$) of Costa Rica in 2000 to that in 2001?
Your answer should be very brief. 0.57. What is the ratio of the Grants(current US$) in Oman in 2000 to that in 2001?
Your response must be concise. 1.49. What is the ratio of the Grants(current US$) in Russian Federation in 2000 to that in 2001?
Your answer should be compact. 0.73. What is the ratio of the Grants(current US$) in United Arab Emirates in 2000 to that in 2001?
Provide a short and direct response. 1.45. What is the ratio of the Grants(current US$) of Costa Rica in 2000 to that in 2002?
Offer a very short reply. 0.82. What is the ratio of the Grants(current US$) in Oman in 2000 to that in 2002?
Your answer should be very brief. 3.24. What is the ratio of the Grants(current US$) of Russian Federation in 2000 to that in 2002?
Your response must be concise. 0.52. What is the ratio of the Grants(current US$) of United Arab Emirates in 2000 to that in 2002?
Your response must be concise. 0.87. What is the ratio of the Grants(current US$) of Costa Rica in 2001 to that in 2002?
Give a very brief answer. 1.45. What is the ratio of the Grants(current US$) in Oman in 2001 to that in 2002?
Give a very brief answer. 2.18. What is the ratio of the Grants(current US$) of Russian Federation in 2001 to that in 2002?
Provide a short and direct response. 0.72. What is the ratio of the Grants(current US$) in United Arab Emirates in 2001 to that in 2002?
Your response must be concise. 0.6. What is the difference between the highest and the second highest Grants(current US$) of Costa Rica?
Provide a succinct answer. 1.28e+07. What is the difference between the highest and the second highest Grants(current US$) of Oman?
Make the answer very short. 5.67e+06. What is the difference between the highest and the second highest Grants(current US$) of Russian Federation?
Provide a short and direct response. 2.51e+08. What is the difference between the highest and the second highest Grants(current US$) in United Arab Emirates?
Your response must be concise. 3.23e+06. What is the difference between the highest and the lowest Grants(current US$) of Costa Rica?
Ensure brevity in your answer.  3.35e+07. What is the difference between the highest and the lowest Grants(current US$) in Oman?
Keep it short and to the point. 1.92e+07. What is the difference between the highest and the lowest Grants(current US$) in Russian Federation?
Your answer should be very brief. 6.79e+08. What is the difference between the highest and the lowest Grants(current US$) in United Arab Emirates?
Your response must be concise. 5.65e+06. 